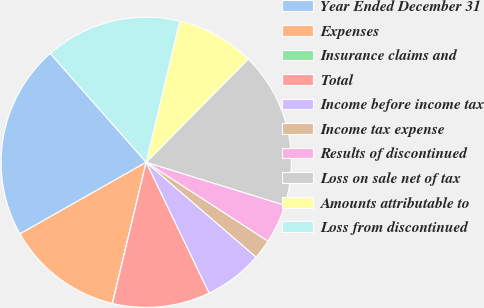Convert chart. <chart><loc_0><loc_0><loc_500><loc_500><pie_chart><fcel>Year Ended December 31<fcel>Expenses<fcel>Insurance claims and<fcel>Total<fcel>Income before income tax<fcel>Income tax expense<fcel>Results of discontinued<fcel>Loss on sale net of tax<fcel>Amounts attributable to<fcel>Loss from discontinued<nl><fcel>21.71%<fcel>13.04%<fcel>0.02%<fcel>10.87%<fcel>6.53%<fcel>2.19%<fcel>4.36%<fcel>17.38%<fcel>8.7%<fcel>15.21%<nl></chart> 